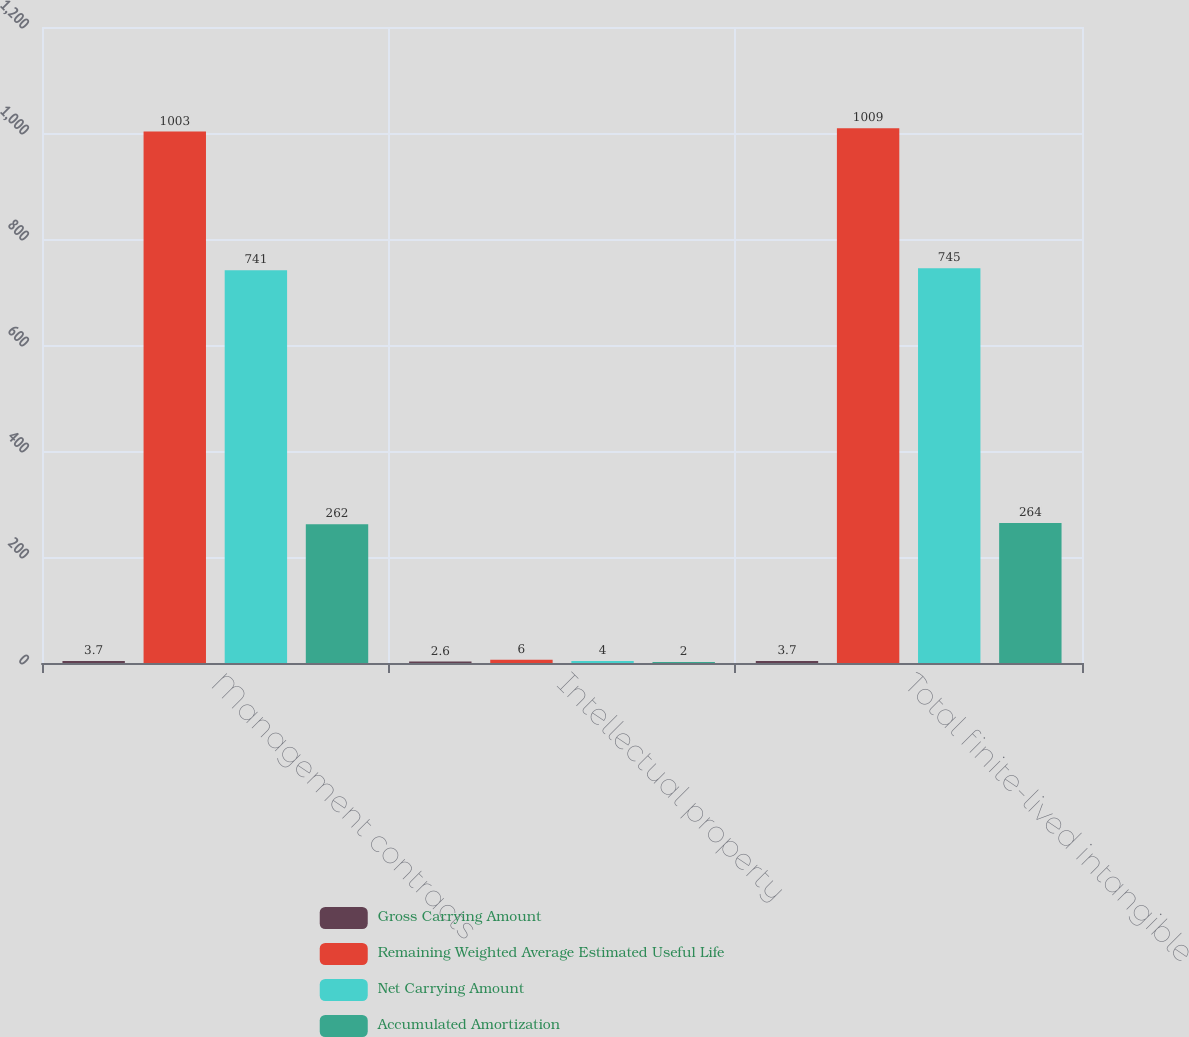Convert chart to OTSL. <chart><loc_0><loc_0><loc_500><loc_500><stacked_bar_chart><ecel><fcel>Management contracts<fcel>Intellectual property<fcel>Total finite-lived intangible<nl><fcel>Gross Carrying Amount<fcel>3.7<fcel>2.6<fcel>3.7<nl><fcel>Remaining Weighted Average Estimated Useful Life<fcel>1003<fcel>6<fcel>1009<nl><fcel>Net Carrying Amount<fcel>741<fcel>4<fcel>745<nl><fcel>Accumulated Amortization<fcel>262<fcel>2<fcel>264<nl></chart> 